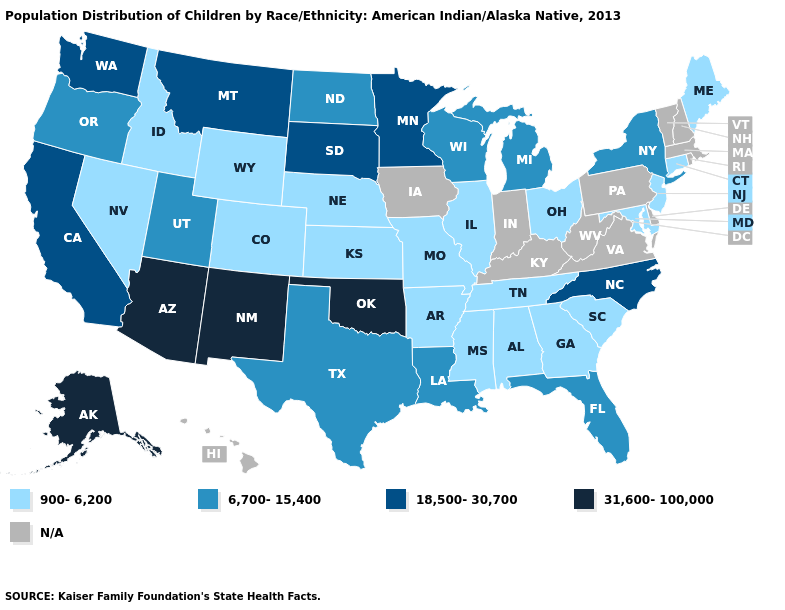Does the map have missing data?
Be succinct. Yes. Among the states that border Idaho , does Nevada have the lowest value?
Write a very short answer. Yes. Among the states that border Florida , which have the highest value?
Give a very brief answer. Alabama, Georgia. Name the states that have a value in the range 6,700-15,400?
Short answer required. Florida, Louisiana, Michigan, New York, North Dakota, Oregon, Texas, Utah, Wisconsin. Does New Jersey have the highest value in the USA?
Quick response, please. No. Name the states that have a value in the range 900-6,200?
Keep it brief. Alabama, Arkansas, Colorado, Connecticut, Georgia, Idaho, Illinois, Kansas, Maine, Maryland, Mississippi, Missouri, Nebraska, Nevada, New Jersey, Ohio, South Carolina, Tennessee, Wyoming. Does Texas have the lowest value in the South?
Concise answer only. No. Name the states that have a value in the range 900-6,200?
Concise answer only. Alabama, Arkansas, Colorado, Connecticut, Georgia, Idaho, Illinois, Kansas, Maine, Maryland, Mississippi, Missouri, Nebraska, Nevada, New Jersey, Ohio, South Carolina, Tennessee, Wyoming. Which states have the lowest value in the Northeast?
Answer briefly. Connecticut, Maine, New Jersey. Name the states that have a value in the range N/A?
Keep it brief. Delaware, Hawaii, Indiana, Iowa, Kentucky, Massachusetts, New Hampshire, Pennsylvania, Rhode Island, Vermont, Virginia, West Virginia. Which states hav the highest value in the South?
Keep it brief. Oklahoma. Name the states that have a value in the range 900-6,200?
Be succinct. Alabama, Arkansas, Colorado, Connecticut, Georgia, Idaho, Illinois, Kansas, Maine, Maryland, Mississippi, Missouri, Nebraska, Nevada, New Jersey, Ohio, South Carolina, Tennessee, Wyoming. Among the states that border Nebraska , does South Dakota have the lowest value?
Be succinct. No. 